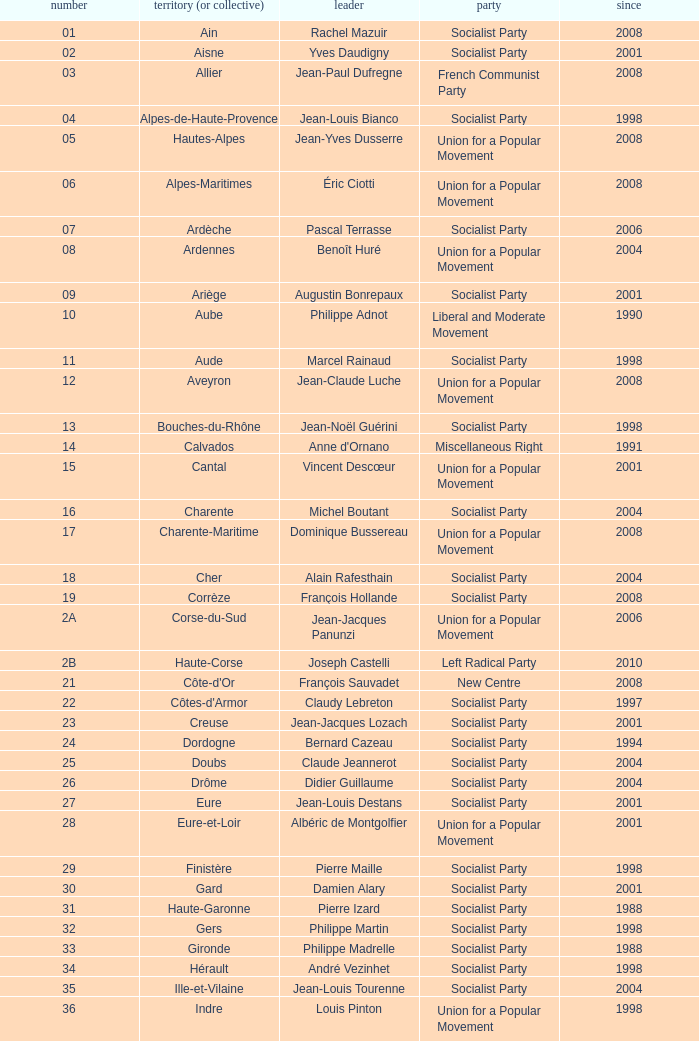Who is the president representing the Creuse department? Jean-Jacques Lozach. 